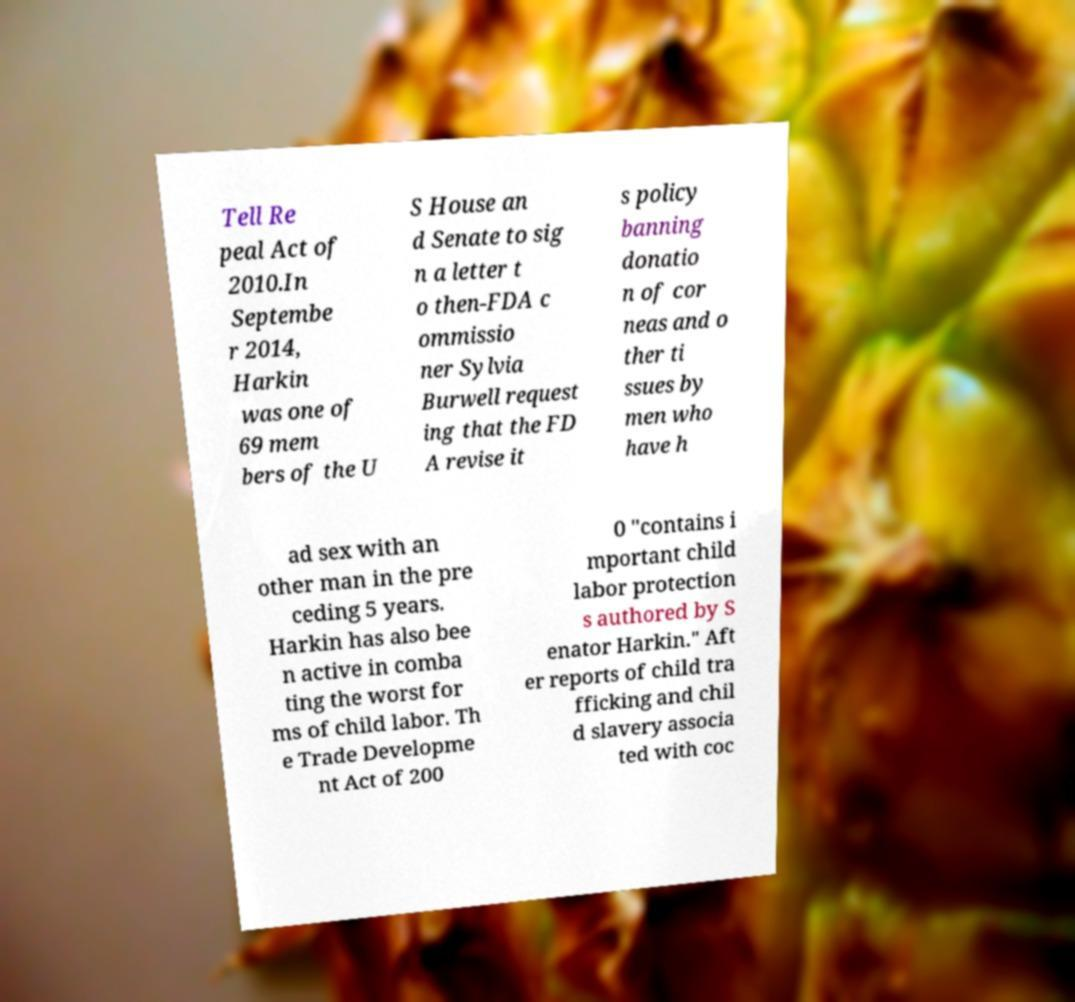Could you extract and type out the text from this image? Tell Re peal Act of 2010.In Septembe r 2014, Harkin was one of 69 mem bers of the U S House an d Senate to sig n a letter t o then-FDA c ommissio ner Sylvia Burwell request ing that the FD A revise it s policy banning donatio n of cor neas and o ther ti ssues by men who have h ad sex with an other man in the pre ceding 5 years. Harkin has also bee n active in comba ting the worst for ms of child labor. Th e Trade Developme nt Act of 200 0 "contains i mportant child labor protection s authored by S enator Harkin." Aft er reports of child tra fficking and chil d slavery associa ted with coc 